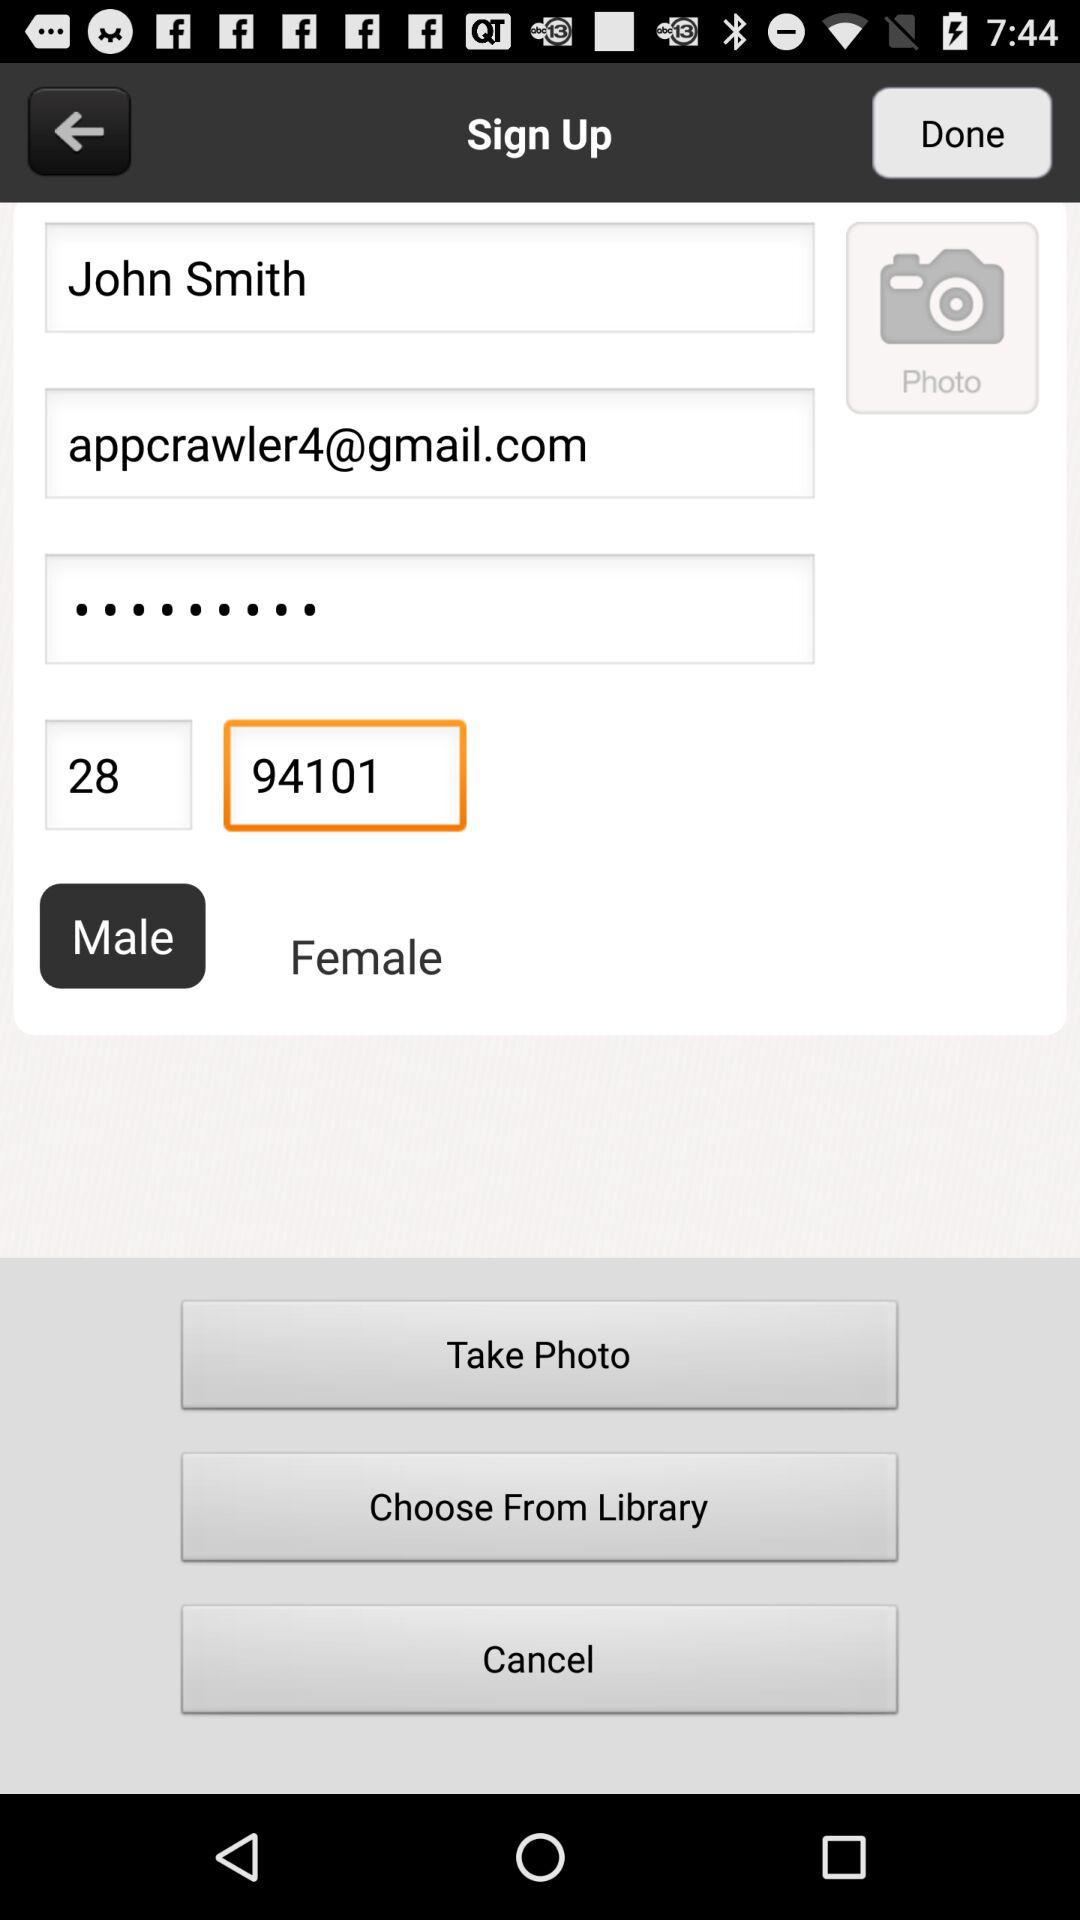What is the selected gender? The selected gender is male. 